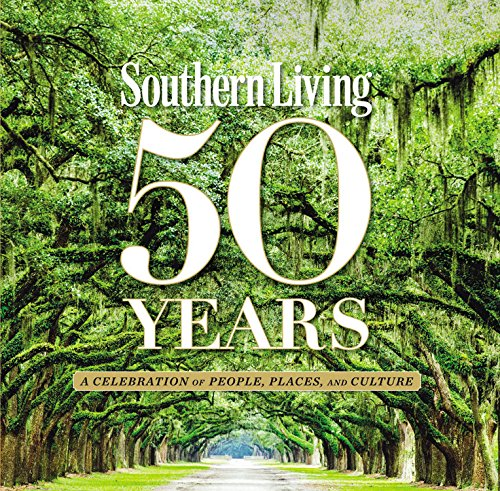What is the genre of this book? This book falls under the 'Cookbooks, Food & Wine' genre, encompassing a wide array of recipes, culinary insights, and gastronomic traditions of the Southern United States. 